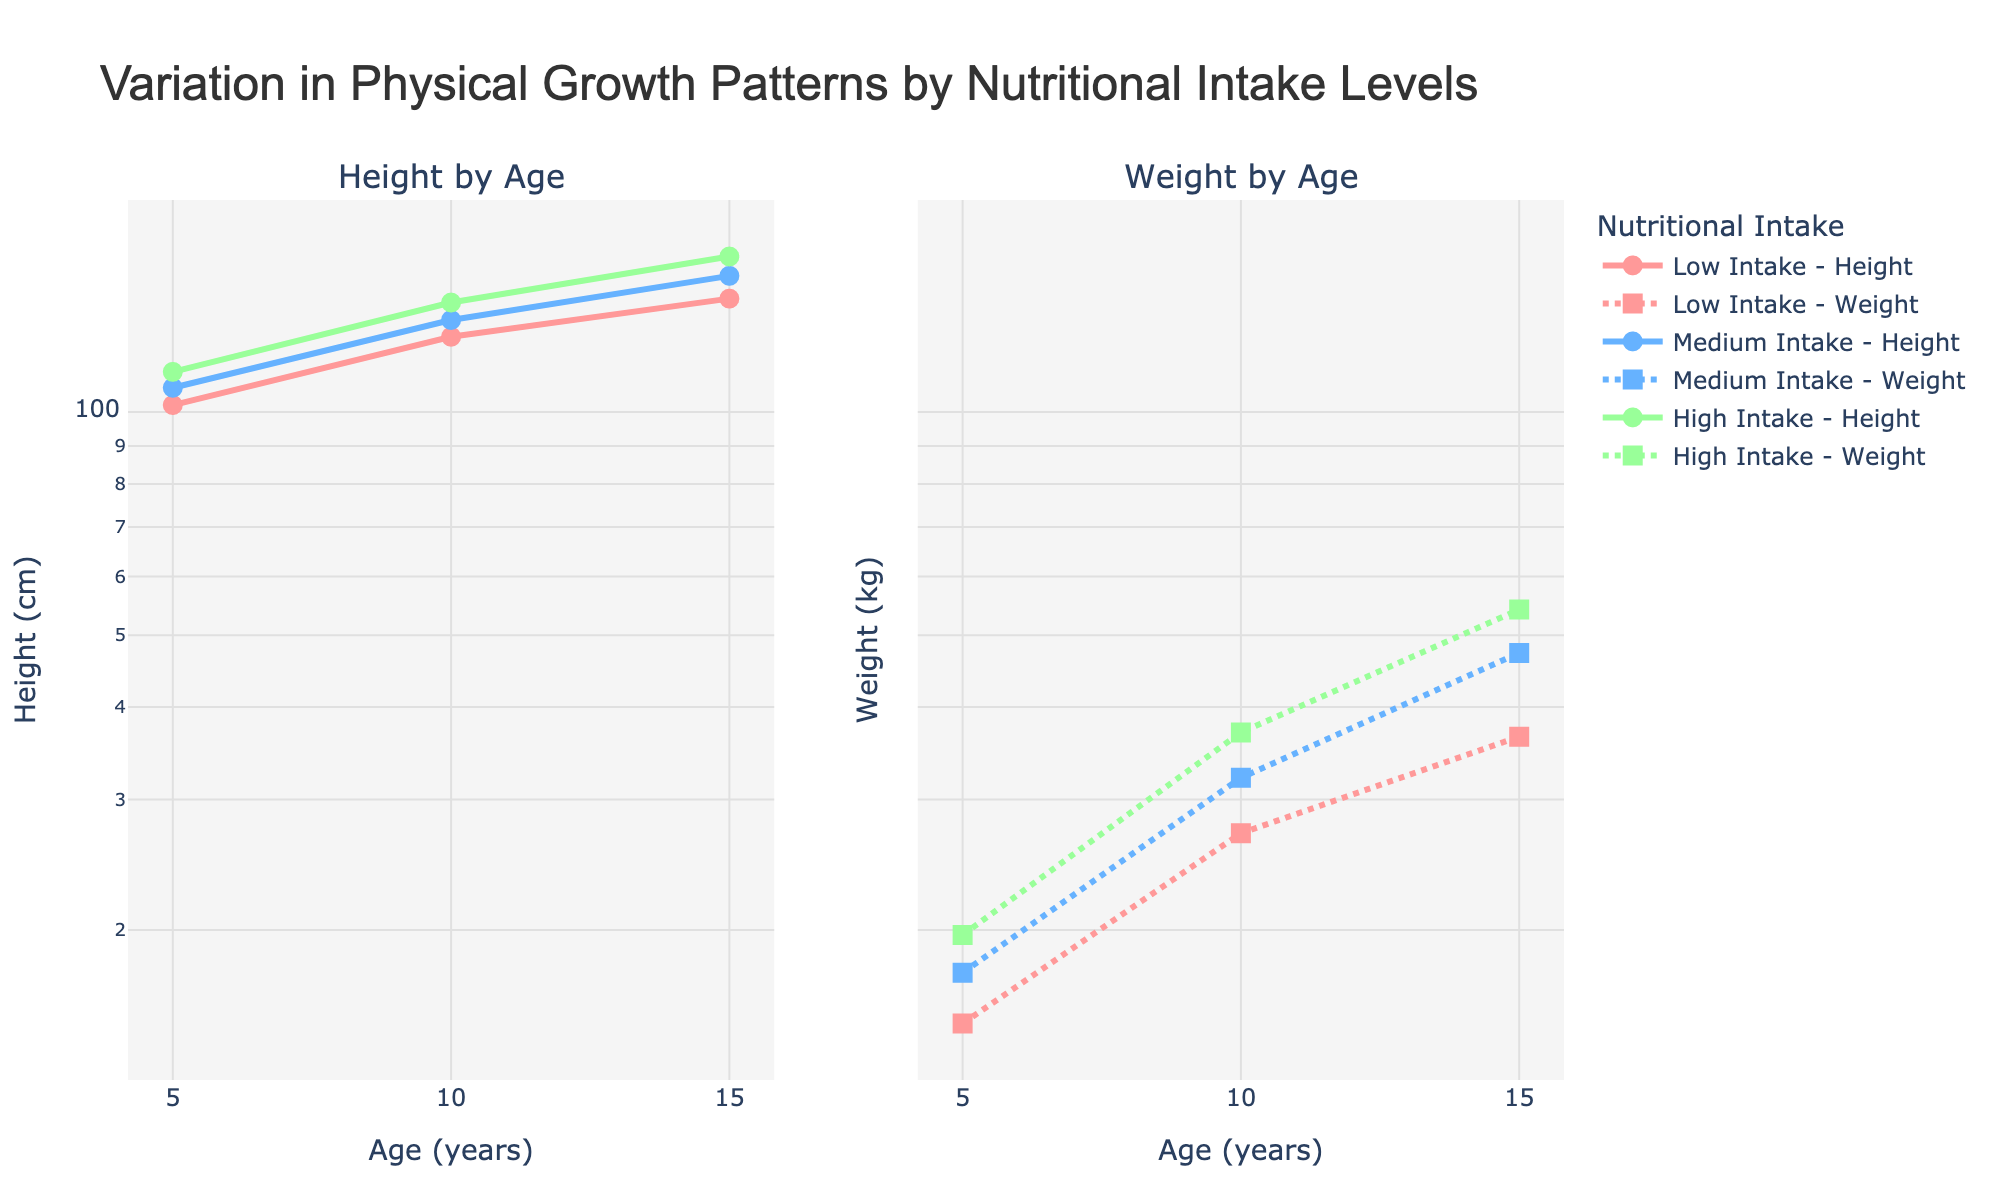what is the title of the figure? The title is placed at the top of the chart, typically in large, bold font. The title of the figure is "Variation in Physical Growth Patterns by Nutritional Intake Levels".
Answer: "Variation in Physical Growth Patterns by Nutritional Intake Levels" What are the age groups shown on the x-axis? The x-axis shows ages in years, mentioned as 5, 10, and 15.
Answer: 5, 10, 15 Which intake group shows the highest average height at age 10? The plotted lines for height highlight the average heights for different intake levels at varying ages. The 'High' intake group shows the highest average height at age 10.
Answer: High How do you interpret the log scale on the y-axes? On a log scale, equal distances represent equal ratios. The y-axes have a log scale, which means each step on the scale corresponds to multiplying by a certain factor, usually 10. This helps in visualizing data spread over a wide range.
Answer: Equal ratios Which intake level exhibits the greatest increase in average weight from age 5 to age 10? The steepness of the line segments between age 5 and age 10 for weight provides insight. 'High' intake level shows the greatest increase.
Answer: High Between which ages does the 'Medium' intake level have the smallest increase in average height? By comparing the slopes of different segments for the 'Medium' intake group, the smallest increase in height happens between ages 10 and 15.
Answer: 10 to 15 What are the colors used to represent different intake levels? The colors used in the plots represent different intake levels: 'Low' is red, 'Medium' is blue, and 'High' is green.
Answer: Red, Blue, Green Which nutrient intake group maintains a consistent pattern of being the tallest and heaviest across all age groups? By observing where each line consistently stays higher in the height and weight plots, you can see that the 'High' intake group is consistently the tallest and heaviest across all ages.
Answer: High How does average height for 'Low' and 'Medium' intake groups compare at age 15? By comparing the final points of the lines for 'Low' and 'Medium' on the height plot, 'Medium' intake shows a higher average height than 'Low' intake at age 15.
Answer: Medium is higher Which group shows the least variance in height between ages 5 to 15? Observing the variability and spread of the height lines, the 'Low' intake group shows the least variance in height between ages 5 to 15.
Answer: Low 